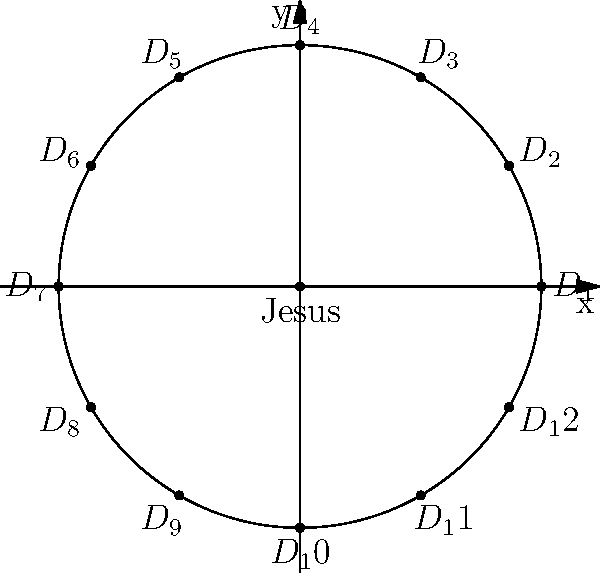In Leonardo da Vinci's "The Last Supper," imagine the disciples arranged in a circle around Jesus, as shown in the diagram. If we use polar coordinates to represent their positions, with Jesus at the origin and the first disciple (D₁) on the positive x-axis, what would be the polar coordinates $(r, \theta)$ of the disciple D₇? (Use radians for the angle and round to two decimal places) To find the polar coordinates of disciple D₇, let's follow these steps:

1. Understand the setup:
   - Jesus is at the origin (0, 0)
   - The disciples form a circle with radius r = 3
   - There are 12 disciples evenly spaced around the circle

2. Calculate the angle between each disciple:
   $\theta_{between} = \frac{2\pi}{12} = \frac{\pi}{6}$ radians

3. Find the angle for D₇:
   - D₇ is the 7th disciple, so we multiply the angle between disciples by 6
   $\theta_7 = 6 \times \frac{\pi}{6} = \pi$ radians

4. The radius remains constant at r = 3

5. Therefore, the polar coordinates of D₇ are:
   $(r, \theta) = (3, \pi)$

6. Rounding to two decimal places:
   $(3.00, 3.14)$
Answer: $(3.00, 3.14)$ 